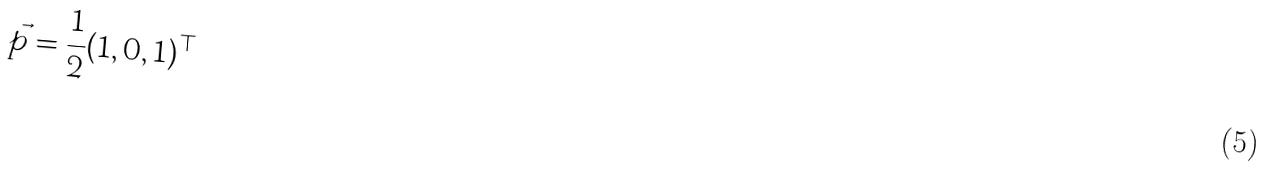Convert formula to latex. <formula><loc_0><loc_0><loc_500><loc_500>\vec { p } = \frac { 1 } { 2 } ( 1 , 0 , 1 ) ^ { \top }</formula> 